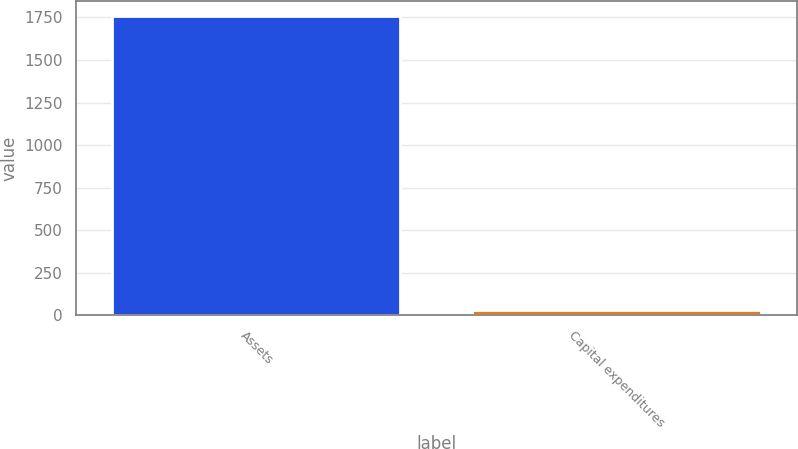<chart> <loc_0><loc_0><loc_500><loc_500><bar_chart><fcel>Assets<fcel>Capital expenditures<nl><fcel>1756<fcel>30<nl></chart> 